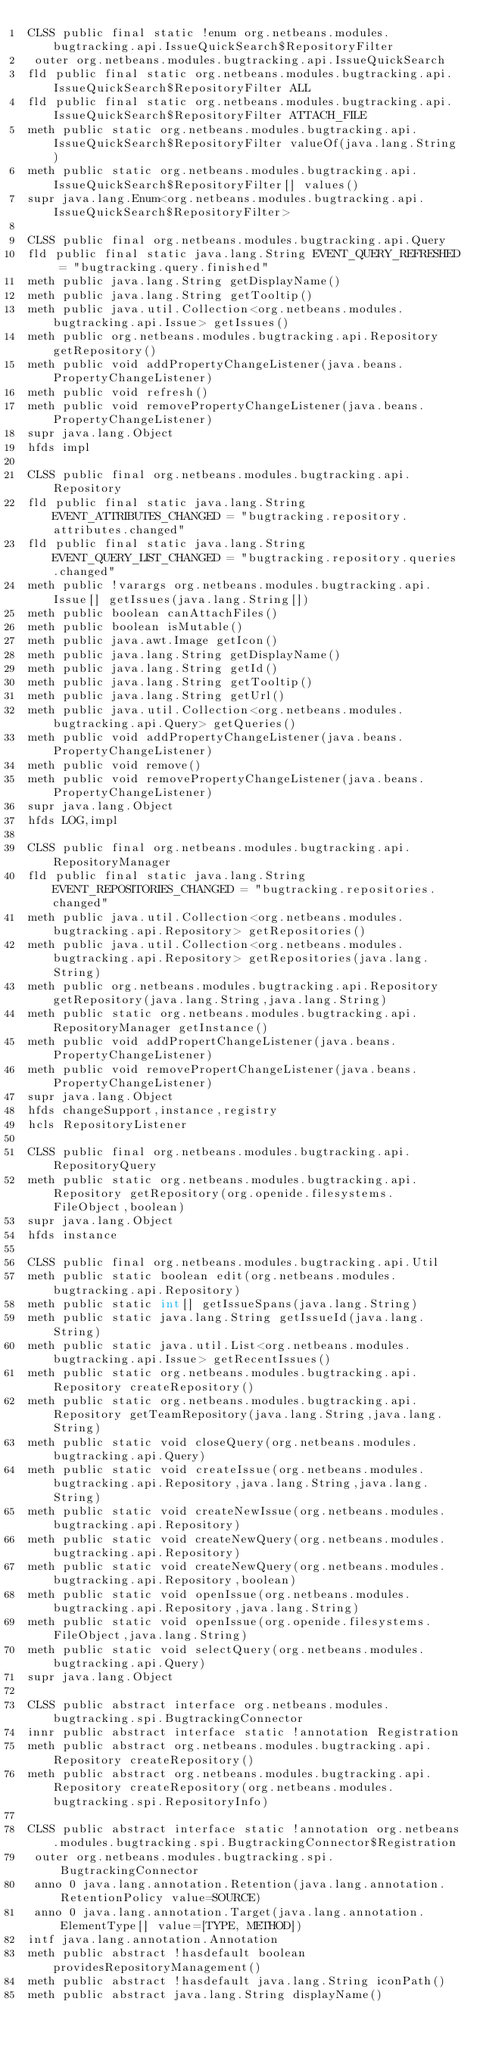Convert code to text. <code><loc_0><loc_0><loc_500><loc_500><_SML_>CLSS public final static !enum org.netbeans.modules.bugtracking.api.IssueQuickSearch$RepositoryFilter
 outer org.netbeans.modules.bugtracking.api.IssueQuickSearch
fld public final static org.netbeans.modules.bugtracking.api.IssueQuickSearch$RepositoryFilter ALL
fld public final static org.netbeans.modules.bugtracking.api.IssueQuickSearch$RepositoryFilter ATTACH_FILE
meth public static org.netbeans.modules.bugtracking.api.IssueQuickSearch$RepositoryFilter valueOf(java.lang.String)
meth public static org.netbeans.modules.bugtracking.api.IssueQuickSearch$RepositoryFilter[] values()
supr java.lang.Enum<org.netbeans.modules.bugtracking.api.IssueQuickSearch$RepositoryFilter>

CLSS public final org.netbeans.modules.bugtracking.api.Query
fld public final static java.lang.String EVENT_QUERY_REFRESHED = "bugtracking.query.finished"
meth public java.lang.String getDisplayName()
meth public java.lang.String getTooltip()
meth public java.util.Collection<org.netbeans.modules.bugtracking.api.Issue> getIssues()
meth public org.netbeans.modules.bugtracking.api.Repository getRepository()
meth public void addPropertyChangeListener(java.beans.PropertyChangeListener)
meth public void refresh()
meth public void removePropertyChangeListener(java.beans.PropertyChangeListener)
supr java.lang.Object
hfds impl

CLSS public final org.netbeans.modules.bugtracking.api.Repository
fld public final static java.lang.String EVENT_ATTRIBUTES_CHANGED = "bugtracking.repository.attributes.changed"
fld public final static java.lang.String EVENT_QUERY_LIST_CHANGED = "bugtracking.repository.queries.changed"
meth public !varargs org.netbeans.modules.bugtracking.api.Issue[] getIssues(java.lang.String[])
meth public boolean canAttachFiles()
meth public boolean isMutable()
meth public java.awt.Image getIcon()
meth public java.lang.String getDisplayName()
meth public java.lang.String getId()
meth public java.lang.String getTooltip()
meth public java.lang.String getUrl()
meth public java.util.Collection<org.netbeans.modules.bugtracking.api.Query> getQueries()
meth public void addPropertyChangeListener(java.beans.PropertyChangeListener)
meth public void remove()
meth public void removePropertyChangeListener(java.beans.PropertyChangeListener)
supr java.lang.Object
hfds LOG,impl

CLSS public final org.netbeans.modules.bugtracking.api.RepositoryManager
fld public final static java.lang.String EVENT_REPOSITORIES_CHANGED = "bugtracking.repositories.changed"
meth public java.util.Collection<org.netbeans.modules.bugtracking.api.Repository> getRepositories()
meth public java.util.Collection<org.netbeans.modules.bugtracking.api.Repository> getRepositories(java.lang.String)
meth public org.netbeans.modules.bugtracking.api.Repository getRepository(java.lang.String,java.lang.String)
meth public static org.netbeans.modules.bugtracking.api.RepositoryManager getInstance()
meth public void addPropertChangeListener(java.beans.PropertyChangeListener)
meth public void removePropertChangeListener(java.beans.PropertyChangeListener)
supr java.lang.Object
hfds changeSupport,instance,registry
hcls RepositoryListener

CLSS public final org.netbeans.modules.bugtracking.api.RepositoryQuery
meth public static org.netbeans.modules.bugtracking.api.Repository getRepository(org.openide.filesystems.FileObject,boolean)
supr java.lang.Object
hfds instance

CLSS public final org.netbeans.modules.bugtracking.api.Util
meth public static boolean edit(org.netbeans.modules.bugtracking.api.Repository)
meth public static int[] getIssueSpans(java.lang.String)
meth public static java.lang.String getIssueId(java.lang.String)
meth public static java.util.List<org.netbeans.modules.bugtracking.api.Issue> getRecentIssues()
meth public static org.netbeans.modules.bugtracking.api.Repository createRepository()
meth public static org.netbeans.modules.bugtracking.api.Repository getTeamRepository(java.lang.String,java.lang.String)
meth public static void closeQuery(org.netbeans.modules.bugtracking.api.Query)
meth public static void createIssue(org.netbeans.modules.bugtracking.api.Repository,java.lang.String,java.lang.String)
meth public static void createNewIssue(org.netbeans.modules.bugtracking.api.Repository)
meth public static void createNewQuery(org.netbeans.modules.bugtracking.api.Repository)
meth public static void createNewQuery(org.netbeans.modules.bugtracking.api.Repository,boolean)
meth public static void openIssue(org.netbeans.modules.bugtracking.api.Repository,java.lang.String)
meth public static void openIssue(org.openide.filesystems.FileObject,java.lang.String)
meth public static void selectQuery(org.netbeans.modules.bugtracking.api.Query)
supr java.lang.Object

CLSS public abstract interface org.netbeans.modules.bugtracking.spi.BugtrackingConnector
innr public abstract interface static !annotation Registration
meth public abstract org.netbeans.modules.bugtracking.api.Repository createRepository()
meth public abstract org.netbeans.modules.bugtracking.api.Repository createRepository(org.netbeans.modules.bugtracking.spi.RepositoryInfo)

CLSS public abstract interface static !annotation org.netbeans.modules.bugtracking.spi.BugtrackingConnector$Registration
 outer org.netbeans.modules.bugtracking.spi.BugtrackingConnector
 anno 0 java.lang.annotation.Retention(java.lang.annotation.RetentionPolicy value=SOURCE)
 anno 0 java.lang.annotation.Target(java.lang.annotation.ElementType[] value=[TYPE, METHOD])
intf java.lang.annotation.Annotation
meth public abstract !hasdefault boolean providesRepositoryManagement()
meth public abstract !hasdefault java.lang.String iconPath()
meth public abstract java.lang.String displayName()</code> 